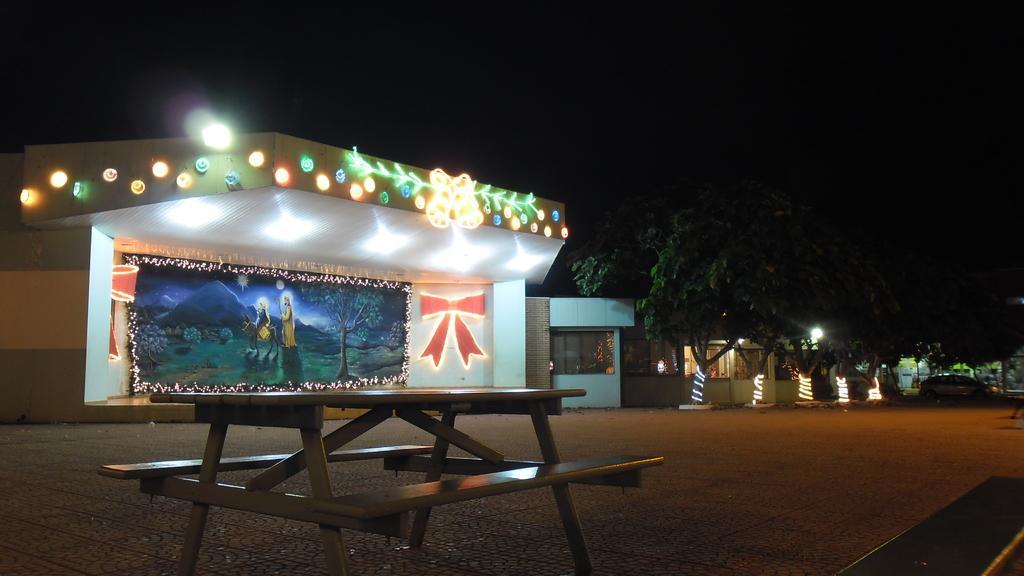Please provide a concise description of this image. In the center of the image there are buildings and we can see decor lights. On the right there are trees and a car. At the bottom there is a bench. 